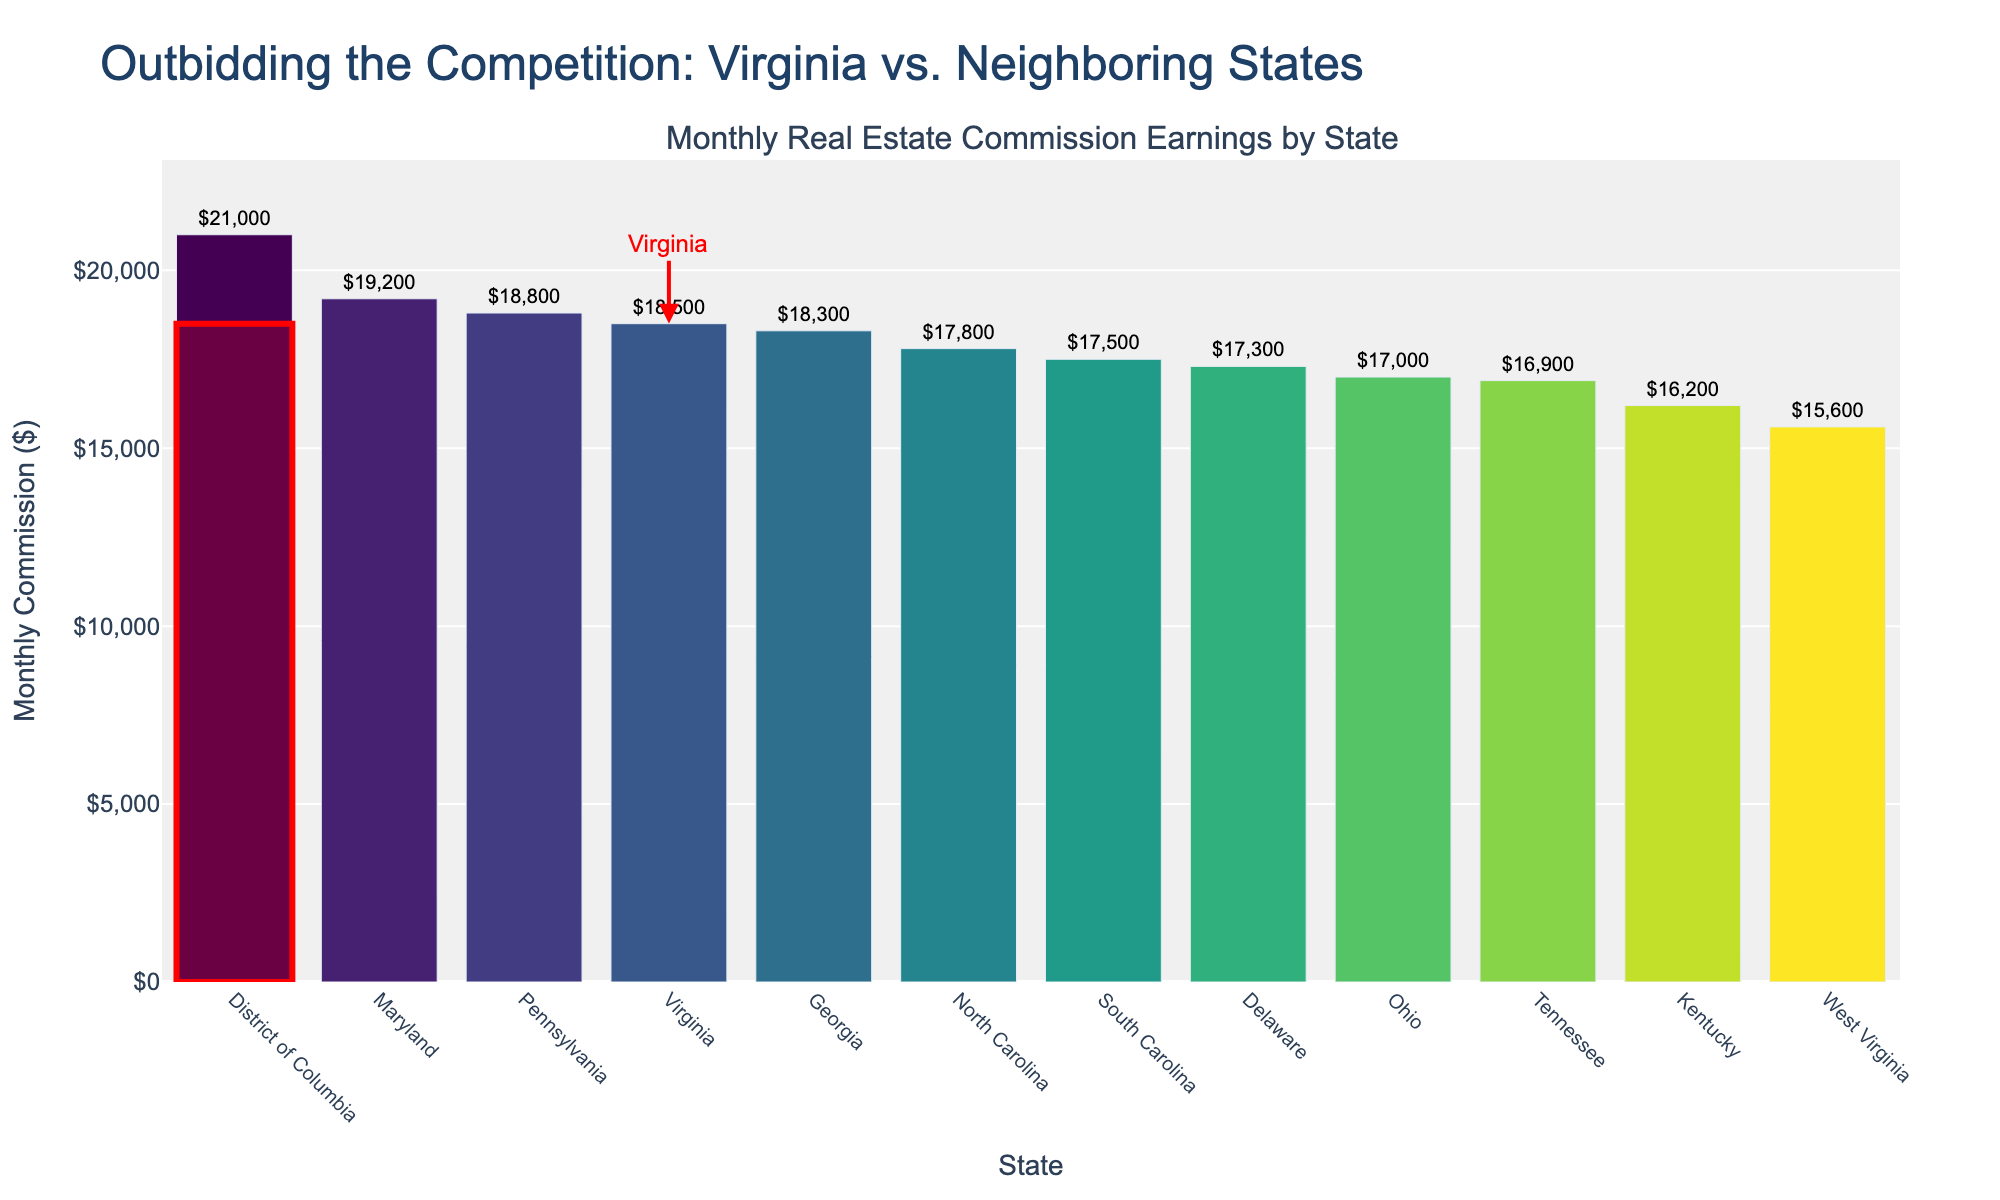How many states have a monthly commission less than Virginia? Count the bars with values lower than the bar for Virginia which is $18,500. These are North Carolina, West Virginia, Tennessee, Kentucky, Delaware, South Carolina, and Ohio.
Answer: 7 Which state has the highest monthly commission earnings? Look at the bar with the highest value; the District of Columbia has the highest value at $21,000.
Answer: District of Columbia What is the difference in monthly commission earnings between Maryland and West Virginia? Subtract West Virginia’s earnings ($15,600) from Maryland’s ($19,200): $19,200 - $15,600 = $3,600.
Answer: $3,600 What is the average monthly commission of all states excluding Virginia? Sum the commissions of all states excluding Virginia, then divide by the number of those states. The sum is ($19,200 + $17,800 + $15,600 + $16,900 + $16,200 + $17,300 + $21,000 + $18,800 + $17,500 + $18,300 + $17,000) = $195,600. Divide by 11 states: $195,600 / 11 ≈ $17,782
Answer: $17,782 Which states earn more than Virginia in monthly commissions? Identify bars with higher values than Virginia's bar ($18,500): Maryland ($19,200), District of Columbia ($21,000), and Pennsylvania ($18,800).
Answer: Maryland, District of Columbia, Pennsylvania What is the range of the monthly commission earnings across all states? Find the difference between the highest and lowest commission values. Highest: District of Columbia ($21,000), lowest: West Virginia ($15,600). Range: $21,000 - $15,600 = $5,400.
Answer: $5,400 How does Virginia's commission earnings compare to the average commission earnings of all states? First, calculate the average commission of all states: Total commission ($214,100) divided by the number of states (12) = $17,841.67. Compare Virginia's earnings ($18,500) to this average.
Answer: Virginia earns above average What is the combined monthly commission of Virginia, Maryland, and District of Columbia? Add their commissions: Virginia ($18,500) + Maryland ($19,200) + District of Columbia ($21,000) = $58,700.
Answer: $58,700 